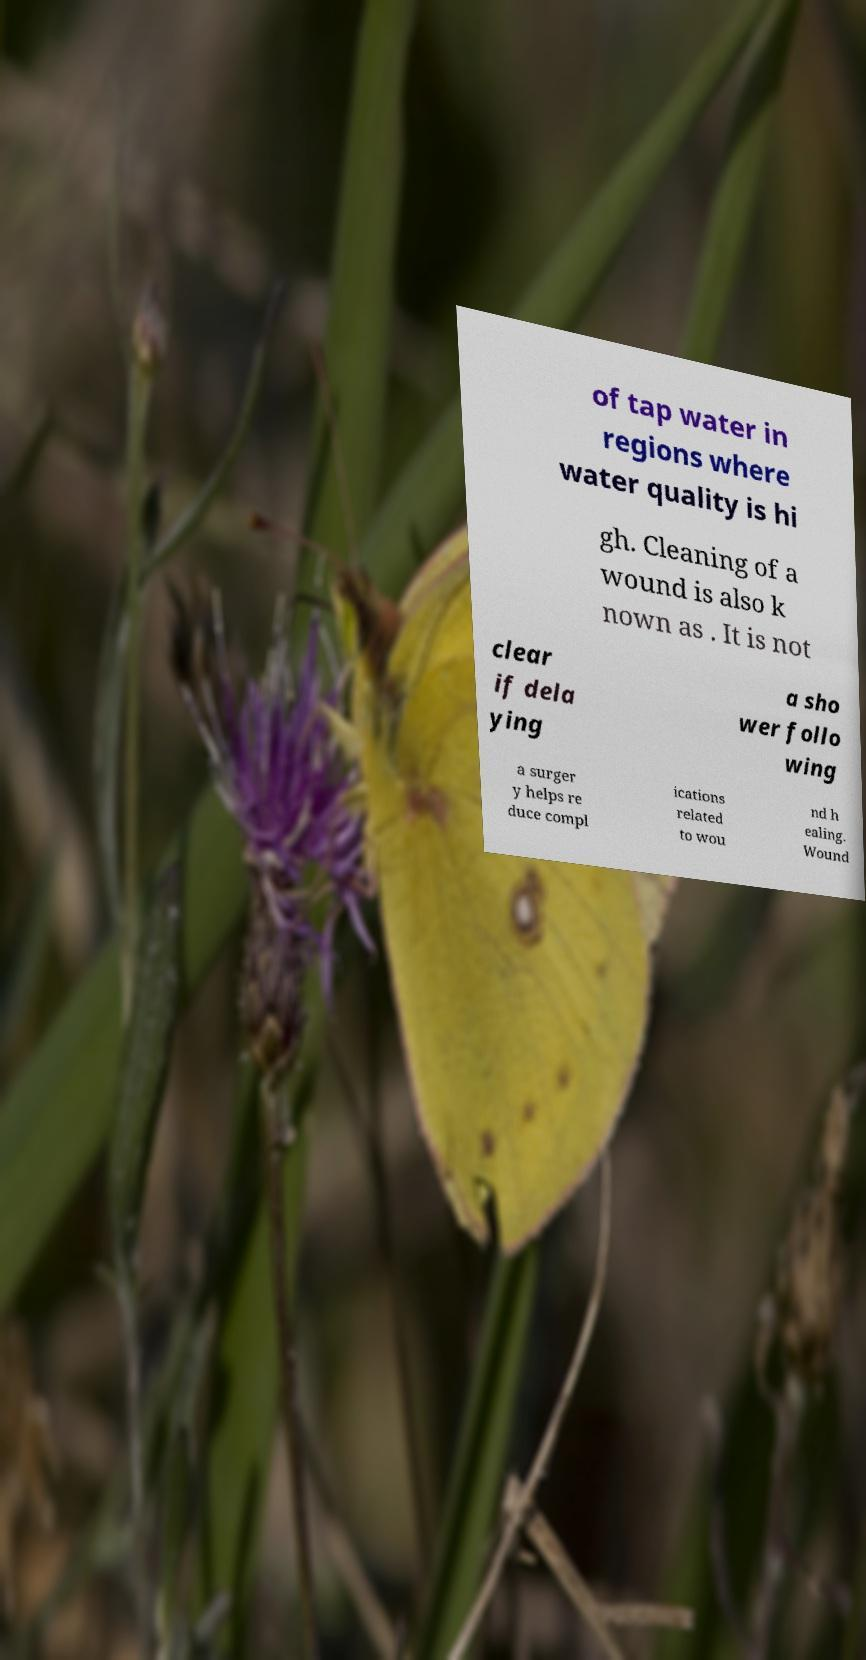For documentation purposes, I need the text within this image transcribed. Could you provide that? of tap water in regions where water quality is hi gh. Cleaning of a wound is also k nown as . It is not clear if dela ying a sho wer follo wing a surger y helps re duce compl ications related to wou nd h ealing. Wound 